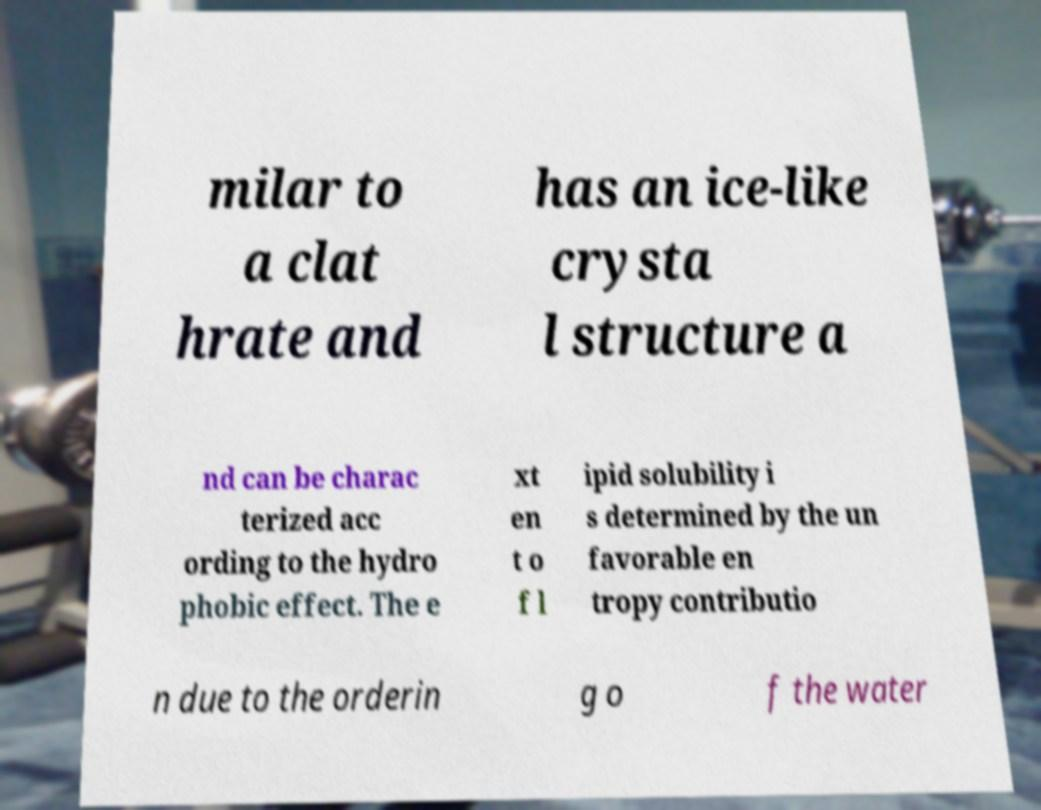Please identify and transcribe the text found in this image. milar to a clat hrate and has an ice-like crysta l structure a nd can be charac terized acc ording to the hydro phobic effect. The e xt en t o f l ipid solubility i s determined by the un favorable en tropy contributio n due to the orderin g o f the water 